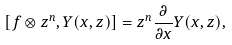<formula> <loc_0><loc_0><loc_500><loc_500>[ f \otimes z ^ { n } , Y ( x , z ) ] = z ^ { n } \frac { \partial } { \partial x } Y ( x , z ) ,</formula> 